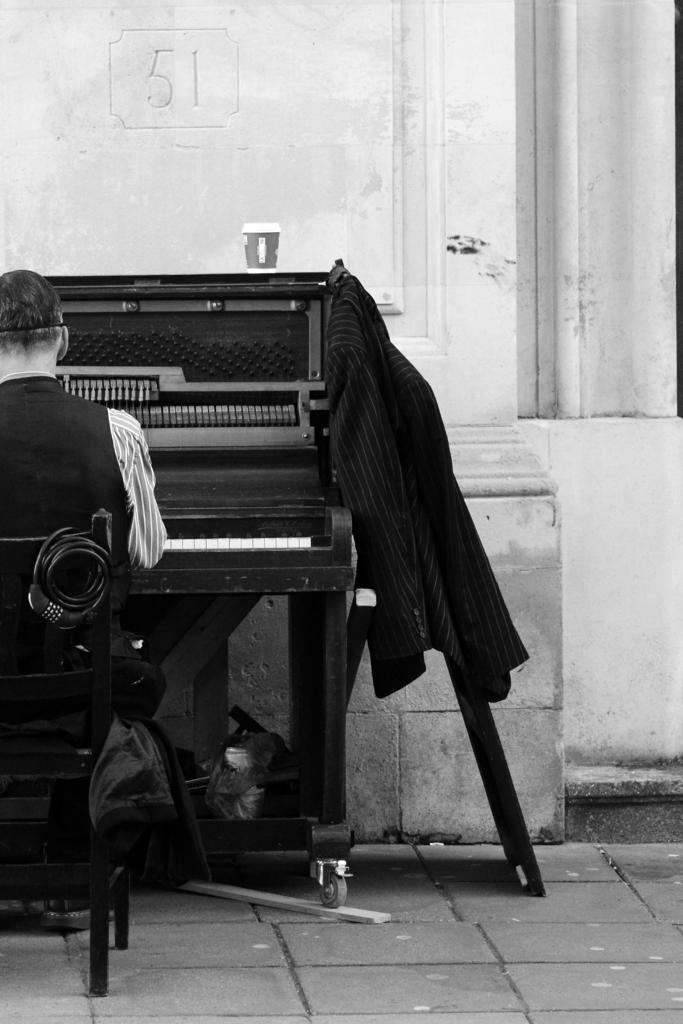In one or two sentences, can you explain what this image depicts? In this image, human is sat on the chair. There is a musical player in this image and suit. There is a wheel. We can see cup is there on the table. And background, there is a wall. 